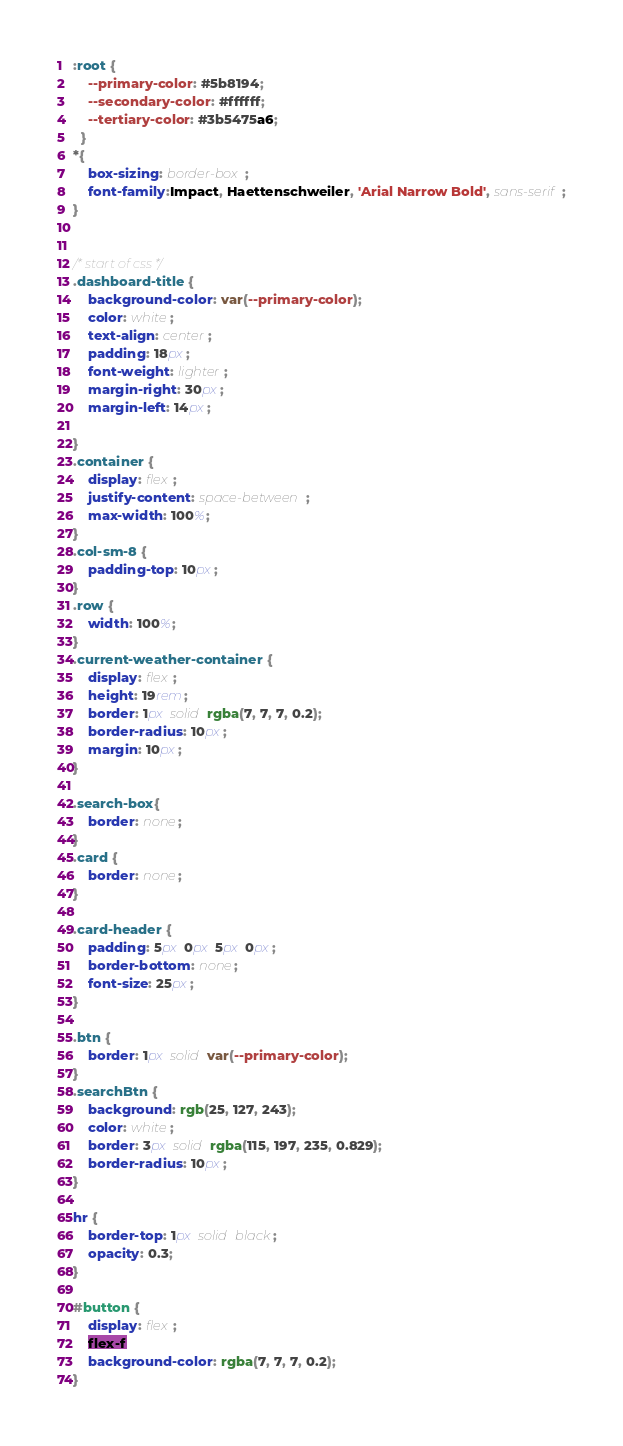Convert code to text. <code><loc_0><loc_0><loc_500><loc_500><_CSS_>:root {
    --primary-color: #5b8194;
    --secondary-color: #ffffff;
    --tertiary-color: #3b5475a6;
  }
*{
    box-sizing: border-box;
    font-family:Impact, Haettenschweiler, 'Arial Narrow Bold', sans-serif;
}


/* start of css */
.dashboard-title {
    background-color: var(--primary-color);
    color: white;
    text-align: center;
    padding: 18px;
    font-weight: lighter;
    margin-right: 30px;
    margin-left: 14px;

}
.container {
    display: flex;
    justify-content: space-between;
    max-width: 100%;
}
.col-sm-8 {
    padding-top: 10px;
}
.row {
    width: 100%;
}
.current-weather-container {
    display: flex;
    height: 19rem;
    border: 1px solid rgba(7, 7, 7, 0.2);
    border-radius: 10px;
    margin: 10px;
}

.search-box{
    border: none;
}
.card {
    border: none;
}

.card-header {
    padding: 5px 0px 5px 0px;
    border-bottom: none;
    font-size: 25px;
}

.btn {
    border: 1px solid var(--primary-color);
}
.searchBtn {
    background: rgb(25, 127, 243);
    color: white;
    border: 3px solid rgba(115, 197, 235, 0.829);
    border-radius: 10px;
}

hr {
    border-top: 1px solid black;
    opacity: 0.3;
}

#button {
    display: flex;
    flex-f
    background-color: rgba(7, 7, 7, 0.2);
}</code> 